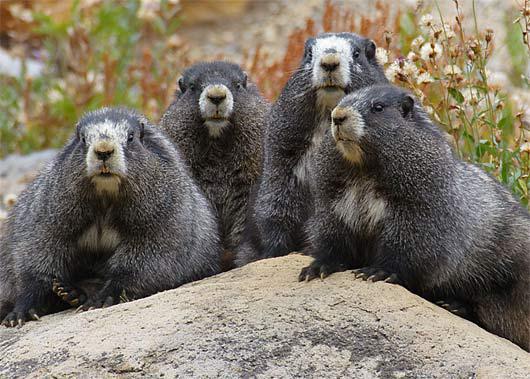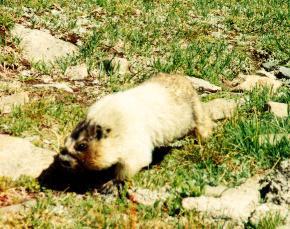The first image is the image on the left, the second image is the image on the right. For the images displayed, is the sentence "An image contains more than one rodent." factually correct? Answer yes or no. Yes. 